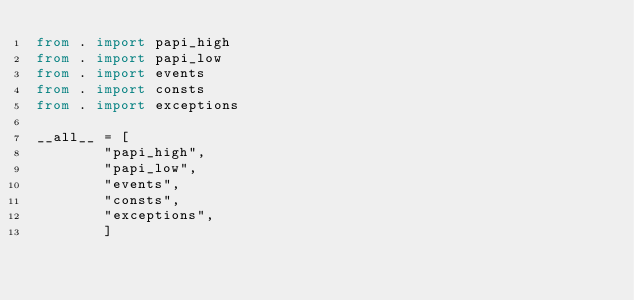<code> <loc_0><loc_0><loc_500><loc_500><_Python_>from . import papi_high
from . import papi_low
from . import events
from . import consts
from . import exceptions

__all__ = [
        "papi_high",
        "papi_low",
        "events",
        "consts",
        "exceptions",
        ]
</code> 